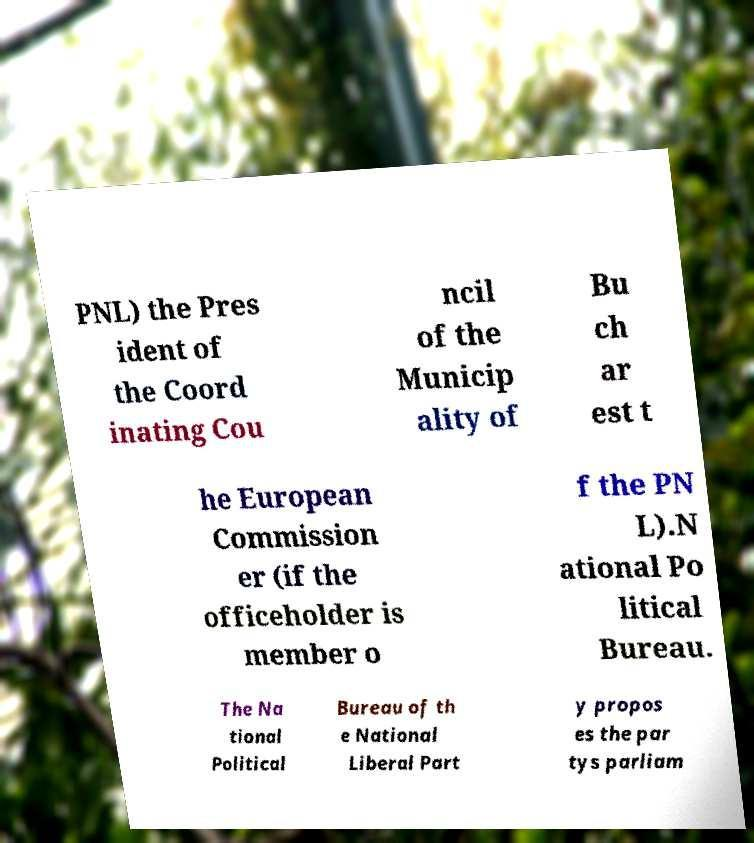For documentation purposes, I need the text within this image transcribed. Could you provide that? PNL) the Pres ident of the Coord inating Cou ncil of the Municip ality of Bu ch ar est t he European Commission er (if the officeholder is member o f the PN L).N ational Po litical Bureau. The Na tional Political Bureau of th e National Liberal Part y propos es the par tys parliam 